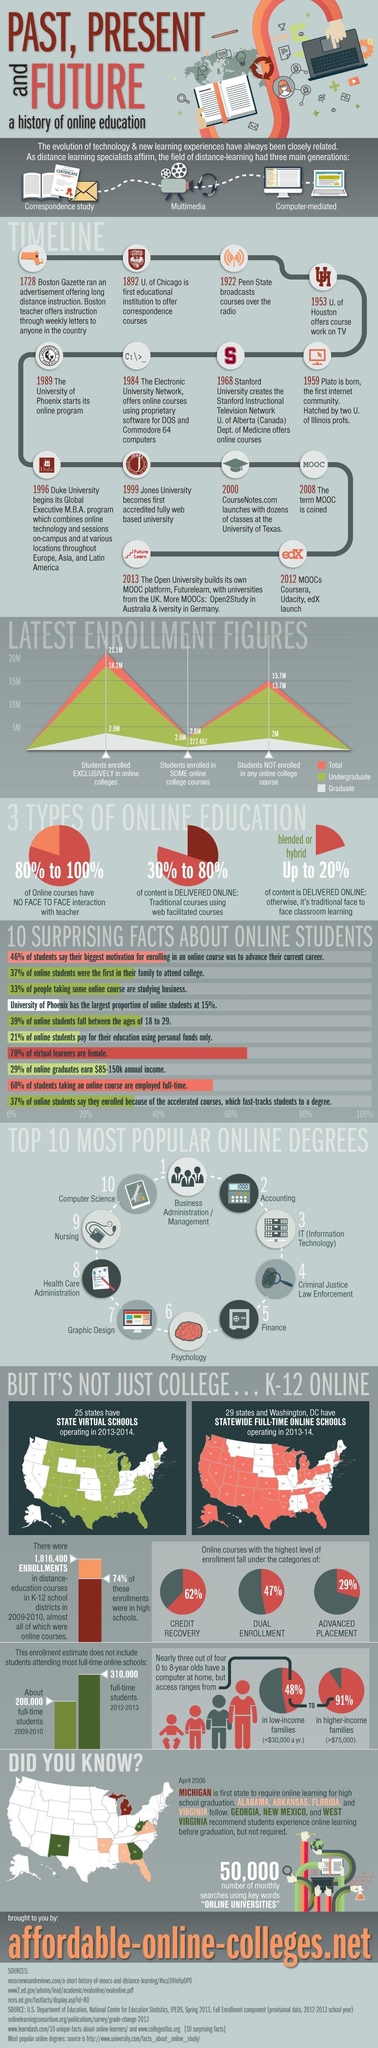Draw attention to some important aspects in this diagram. The color used to represent graduate status is white. The difference between full-time students in the academic years 2009-2010 and 2012-2013 is 110,000. Alabama was the second state to make online learning a graduation requirement. 